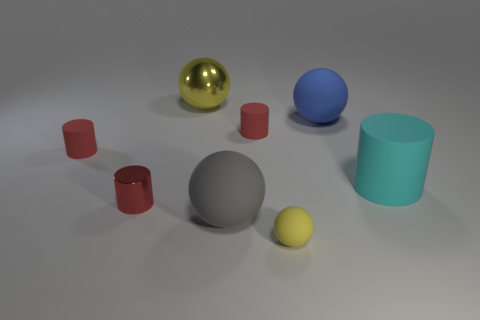What textures are present among the items in this image? The image displays a variety of textures, including the smooth and reflective surface of the golden and blue spheres, the matte and slightly rough surface of the gray and red cylinders, and the diffuse, soft texture of the gray and yellow spheres. 